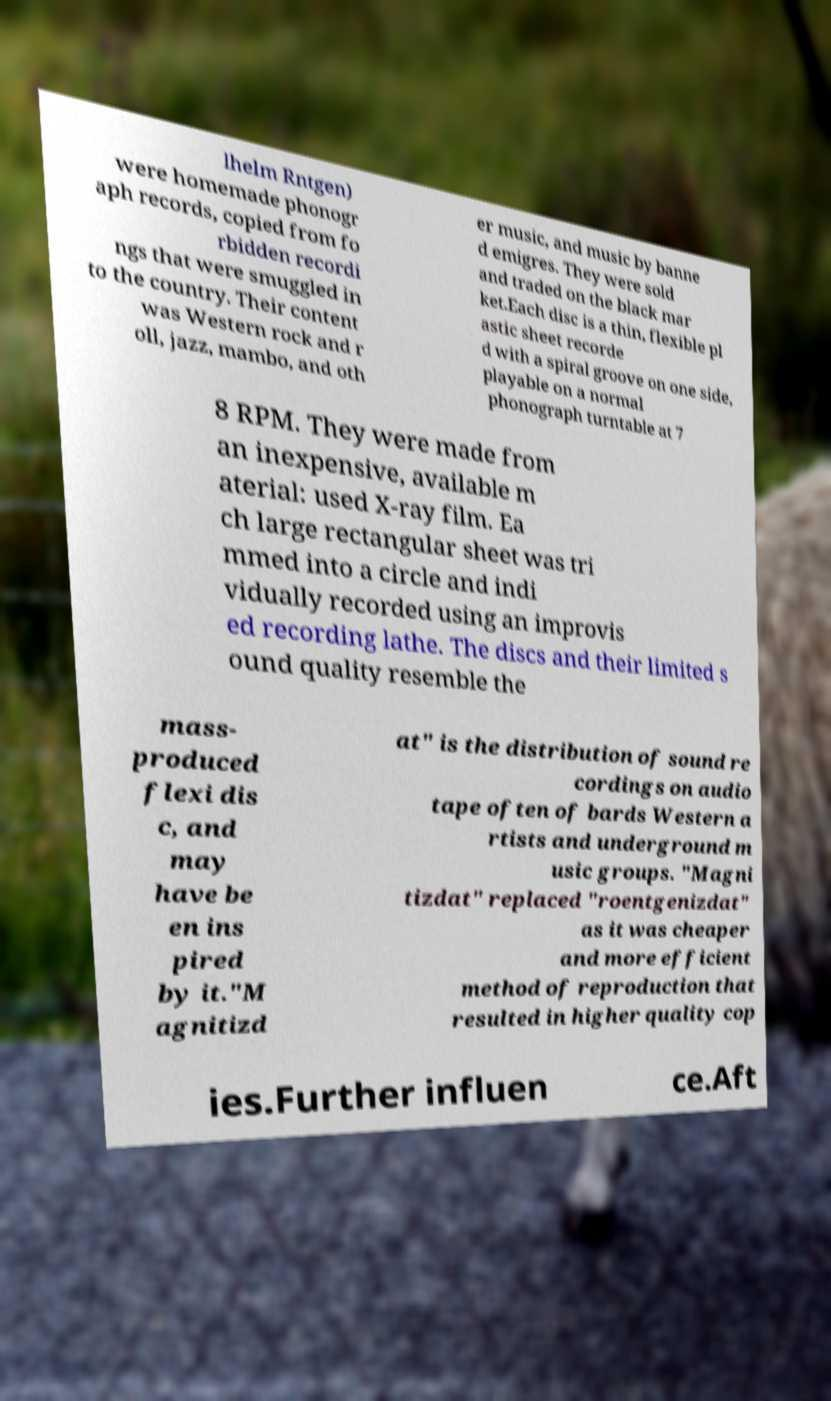Could you extract and type out the text from this image? lhelm Rntgen) were homemade phonogr aph records, copied from fo rbidden recordi ngs that were smuggled in to the country. Their content was Western rock and r oll, jazz, mambo, and oth er music, and music by banne d emigres. They were sold and traded on the black mar ket.Each disc is a thin, flexible pl astic sheet recorde d with a spiral groove on one side, playable on a normal phonograph turntable at 7 8 RPM. They were made from an inexpensive, available m aterial: used X-ray film. Ea ch large rectangular sheet was tri mmed into a circle and indi vidually recorded using an improvis ed recording lathe. The discs and their limited s ound quality resemble the mass- produced flexi dis c, and may have be en ins pired by it."M agnitizd at" is the distribution of sound re cordings on audio tape often of bards Western a rtists and underground m usic groups. "Magni tizdat" replaced "roentgenizdat" as it was cheaper and more efficient method of reproduction that resulted in higher quality cop ies.Further influen ce.Aft 